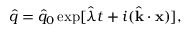<formula> <loc_0><loc_0><loc_500><loc_500>\hat { q } = \hat { q } _ { 0 } \exp [ \hat { \lambda } t + i ( \hat { k } \cdot x ) ] ,</formula> 